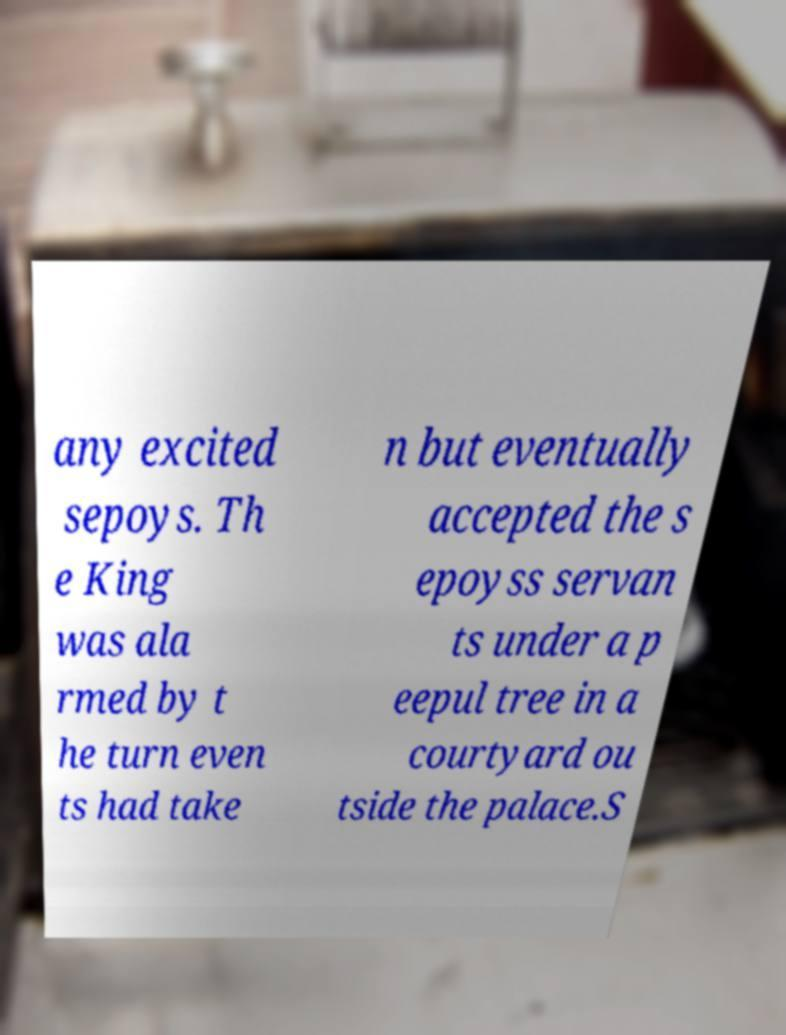Could you assist in decoding the text presented in this image and type it out clearly? any excited sepoys. Th e King was ala rmed by t he turn even ts had take n but eventually accepted the s epoyss servan ts under a p eepul tree in a courtyard ou tside the palace.S 